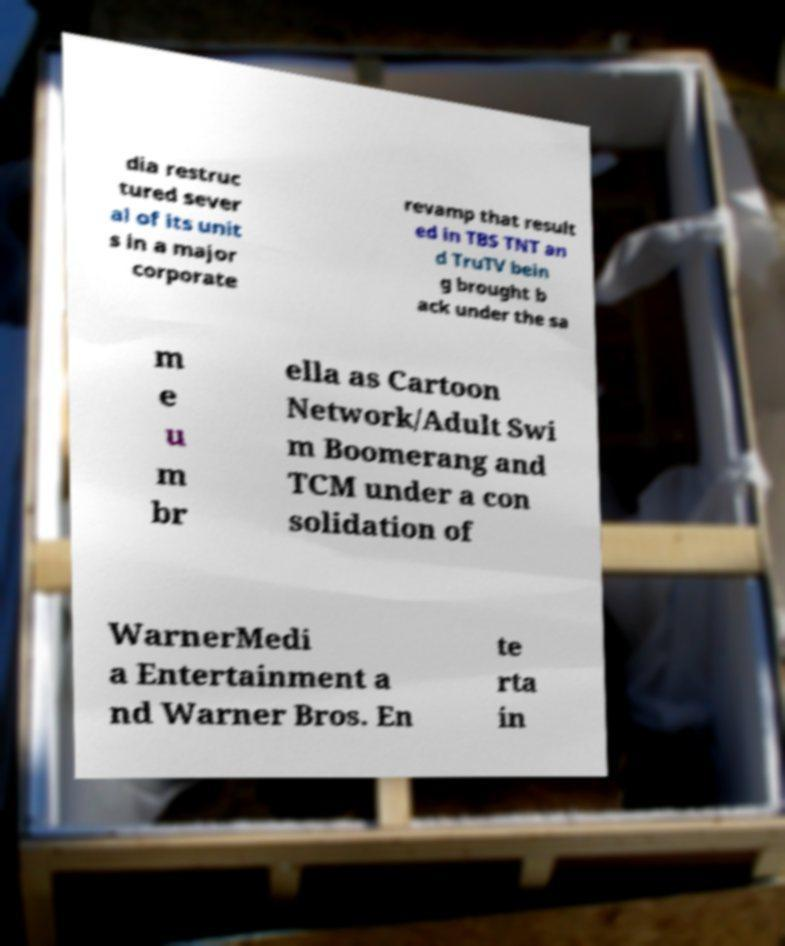Please identify and transcribe the text found in this image. dia restruc tured sever al of its unit s in a major corporate revamp that result ed in TBS TNT an d TruTV bein g brought b ack under the sa m e u m br ella as Cartoon Network/Adult Swi m Boomerang and TCM under a con solidation of WarnerMedi a Entertainment a nd Warner Bros. En te rta in 